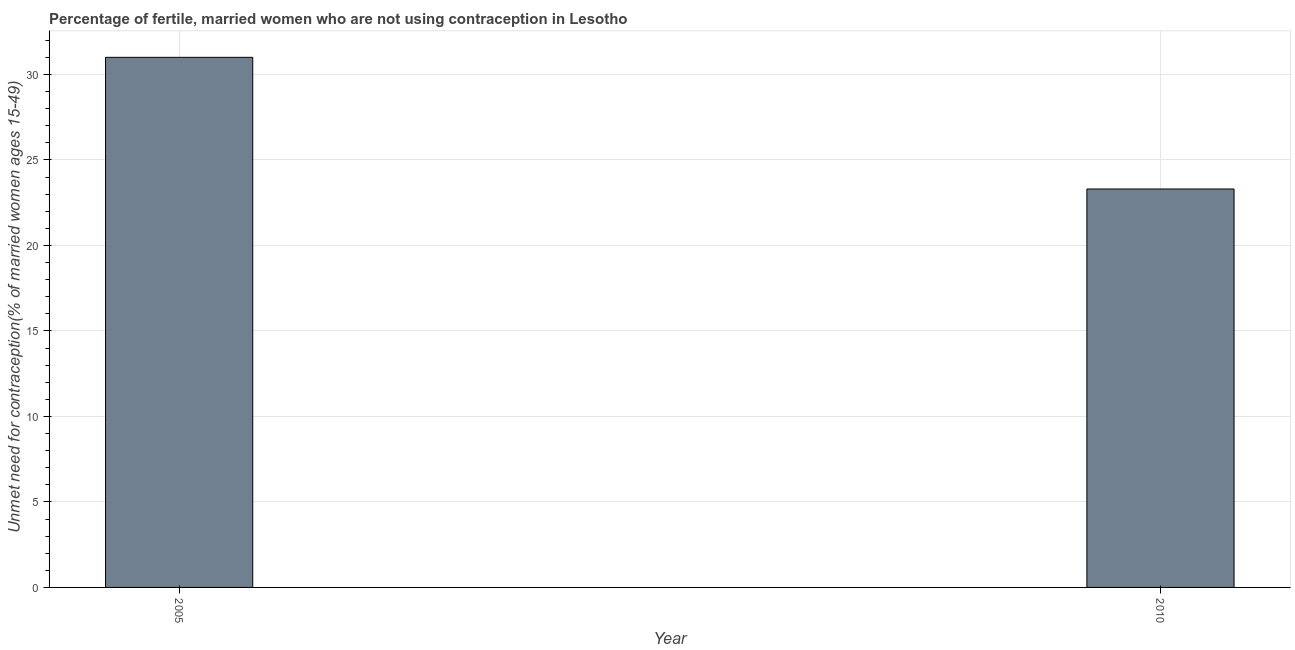Does the graph contain any zero values?
Your answer should be very brief. No. What is the title of the graph?
Your response must be concise. Percentage of fertile, married women who are not using contraception in Lesotho. What is the label or title of the X-axis?
Offer a terse response. Year. What is the label or title of the Y-axis?
Provide a short and direct response.  Unmet need for contraception(% of married women ages 15-49). Across all years, what is the minimum number of married women who are not using contraception?
Make the answer very short. 23.3. In which year was the number of married women who are not using contraception maximum?
Your answer should be compact. 2005. In which year was the number of married women who are not using contraception minimum?
Offer a terse response. 2010. What is the sum of the number of married women who are not using contraception?
Your answer should be compact. 54.3. What is the difference between the number of married women who are not using contraception in 2005 and 2010?
Provide a succinct answer. 7.7. What is the average number of married women who are not using contraception per year?
Provide a succinct answer. 27.15. What is the median number of married women who are not using contraception?
Ensure brevity in your answer.  27.15. In how many years, is the number of married women who are not using contraception greater than 16 %?
Provide a succinct answer. 2. What is the ratio of the number of married women who are not using contraception in 2005 to that in 2010?
Provide a succinct answer. 1.33. In how many years, is the number of married women who are not using contraception greater than the average number of married women who are not using contraception taken over all years?
Ensure brevity in your answer.  1. How many bars are there?
Provide a succinct answer. 2. Are all the bars in the graph horizontal?
Your response must be concise. No. Are the values on the major ticks of Y-axis written in scientific E-notation?
Offer a very short reply. No. What is the  Unmet need for contraception(% of married women ages 15-49) in 2010?
Provide a short and direct response. 23.3. What is the ratio of the  Unmet need for contraception(% of married women ages 15-49) in 2005 to that in 2010?
Provide a short and direct response. 1.33. 